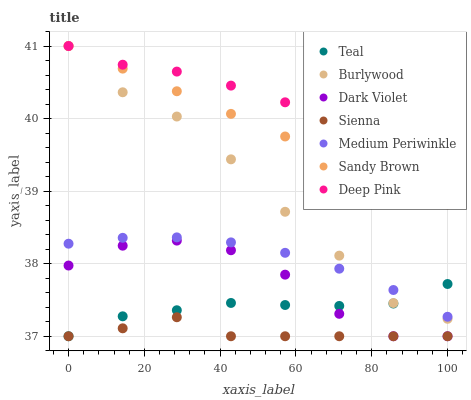Does Sienna have the minimum area under the curve?
Answer yes or no. Yes. Does Deep Pink have the maximum area under the curve?
Answer yes or no. Yes. Does Burlywood have the minimum area under the curve?
Answer yes or no. No. Does Burlywood have the maximum area under the curve?
Answer yes or no. No. Is Sandy Brown the smoothest?
Answer yes or no. Yes. Is Dark Violet the roughest?
Answer yes or no. Yes. Is Burlywood the smoothest?
Answer yes or no. No. Is Burlywood the roughest?
Answer yes or no. No. Does Dark Violet have the lowest value?
Answer yes or no. Yes. Does Burlywood have the lowest value?
Answer yes or no. No. Does Sandy Brown have the highest value?
Answer yes or no. Yes. Does Medium Periwinkle have the highest value?
Answer yes or no. No. Is Medium Periwinkle less than Deep Pink?
Answer yes or no. Yes. Is Medium Periwinkle greater than Sienna?
Answer yes or no. Yes. Does Sienna intersect Teal?
Answer yes or no. Yes. Is Sienna less than Teal?
Answer yes or no. No. Is Sienna greater than Teal?
Answer yes or no. No. Does Medium Periwinkle intersect Deep Pink?
Answer yes or no. No. 